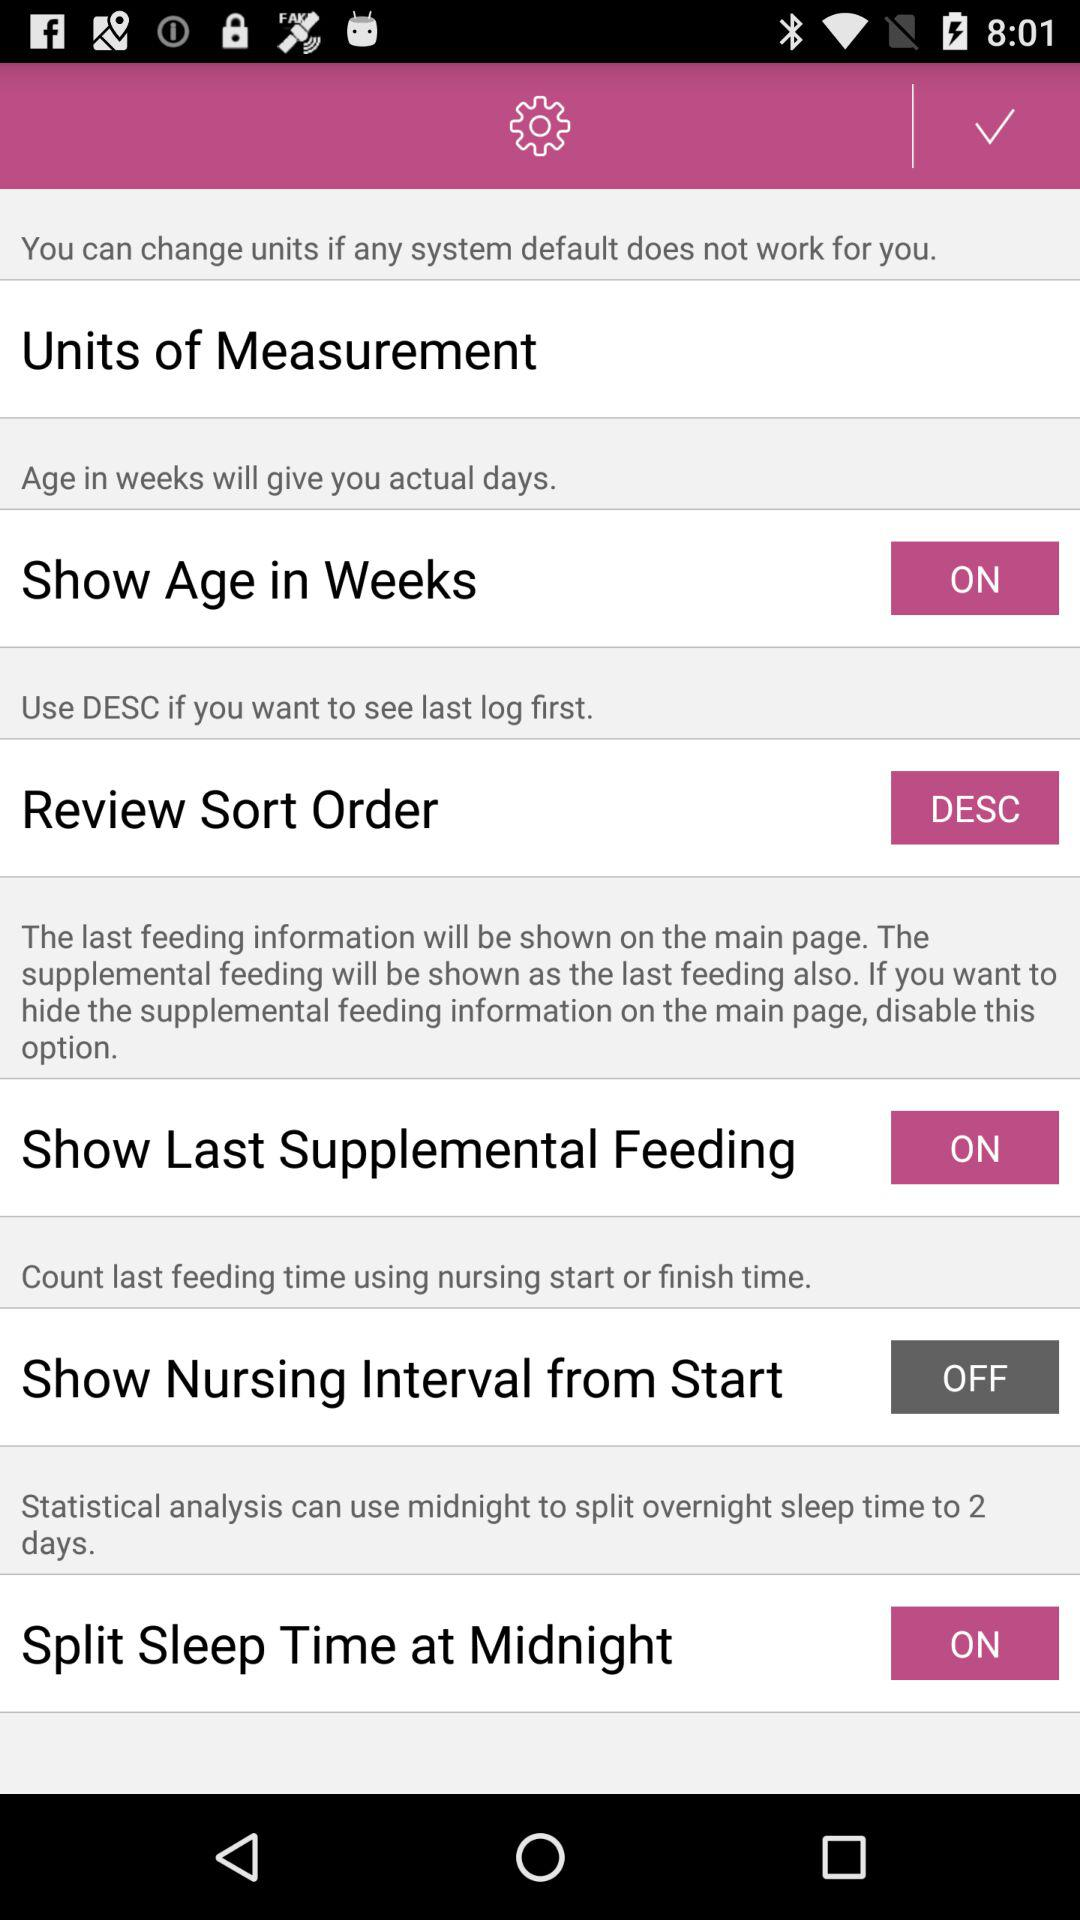What is the current status of the "Split Sleep Time at Midnight" setting? The current status is "on". 